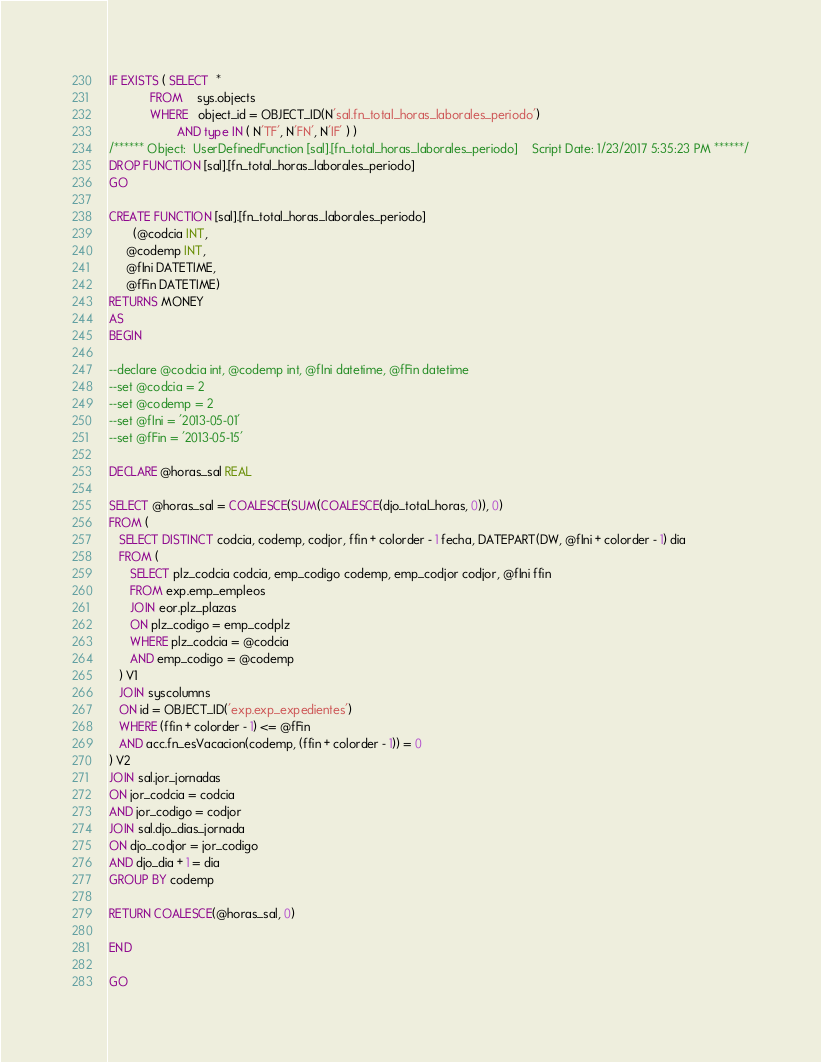Convert code to text. <code><loc_0><loc_0><loc_500><loc_500><_SQL_>
IF EXISTS ( SELECT  *
            FROM    sys.objects
            WHERE   object_id = OBJECT_ID(N'sal.fn_total_horas_laborales_periodo')
                    AND type IN ( N'TF', N'FN', N'IF' ) ) 
/****** Object:  UserDefinedFunction [sal].[fn_total_horas_laborales_periodo]    Script Date: 1/23/2017 5:35:23 PM ******/
DROP FUNCTION [sal].[fn_total_horas_laborales_periodo]
GO

CREATE FUNCTION [sal].[fn_total_horas_laborales_periodo]
       (@codcia INT, 
     @codemp INT,
     @fIni DATETIME,
     @fFin DATETIME)
RETURNS MONEY
AS
BEGIN

--declare @codcia int, @codemp int, @fIni datetime, @fFin datetime
--set @codcia = 2
--set @codemp = 2
--set @fIni = '2013-05-01'
--set @fFin = '2013-05-15'

DECLARE @horas_sal REAL

SELECT @horas_sal = COALESCE(SUM(COALESCE(djo_total_horas, 0)), 0)
FROM (
   SELECT DISTINCT codcia, codemp, codjor, ffin + colorder - 1 fecha, DATEPART(DW, @fIni + colorder - 1) dia
   FROM (
      SELECT plz_codcia codcia, emp_codigo codemp, emp_codjor codjor, @fIni ffin
      FROM exp.emp_empleos
      JOIN eor.plz_plazas
      ON plz_codigo = emp_codplz
      WHERE plz_codcia = @codcia
      AND emp_codigo = @codemp
   ) V1
   JOIN syscolumns
   ON id = OBJECT_ID('exp.exp_expedientes')
   WHERE (ffin + colorder - 1) <= @fFin
   AND acc.fn_esVacacion(codemp, (ffin + colorder - 1)) = 0
) V2
JOIN sal.jor_jornadas
ON jor_codcia = codcia
AND jor_codigo = codjor
JOIN sal.djo_dias_jornada
ON djo_codjor = jor_codigo
AND djo_dia + 1 = dia
GROUP BY codemp

RETURN COALESCE(@horas_sal, 0)

END

GO
</code> 